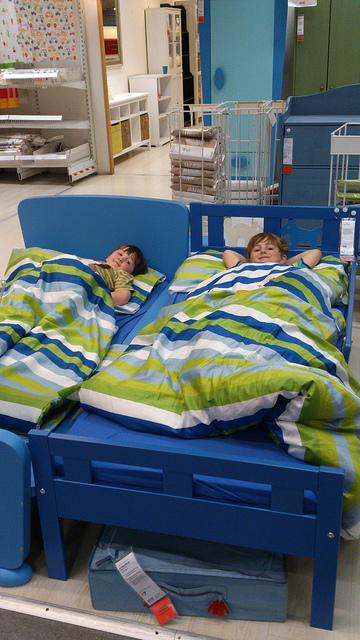Where are the beds that the boys are lying on? Please explain your reasoning. furniture store. The place seems to be a place that takes care of kids. 